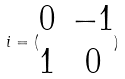Convert formula to latex. <formula><loc_0><loc_0><loc_500><loc_500>i = ( \begin{matrix} 0 & - 1 \\ 1 & 0 \end{matrix} )</formula> 